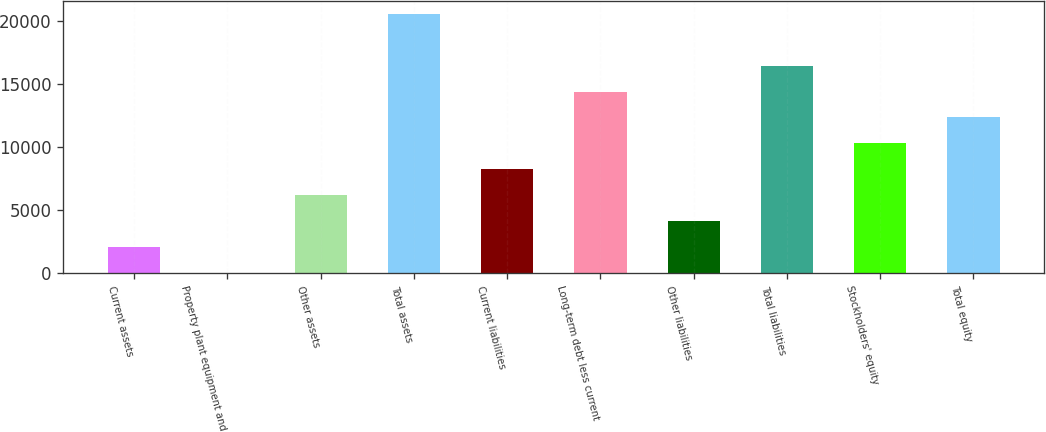Convert chart. <chart><loc_0><loc_0><loc_500><loc_500><bar_chart><fcel>Current assets<fcel>Property plant equipment and<fcel>Other assets<fcel>Total assets<fcel>Current liabilities<fcel>Long-term debt less current<fcel>Other liabilities<fcel>Total liabilities<fcel>Stockholders' equity<fcel>Total equity<nl><fcel>2072.8<fcel>14<fcel>6190.4<fcel>20602<fcel>8249.2<fcel>14425.6<fcel>4131.6<fcel>16484.4<fcel>10308<fcel>12366.8<nl></chart> 